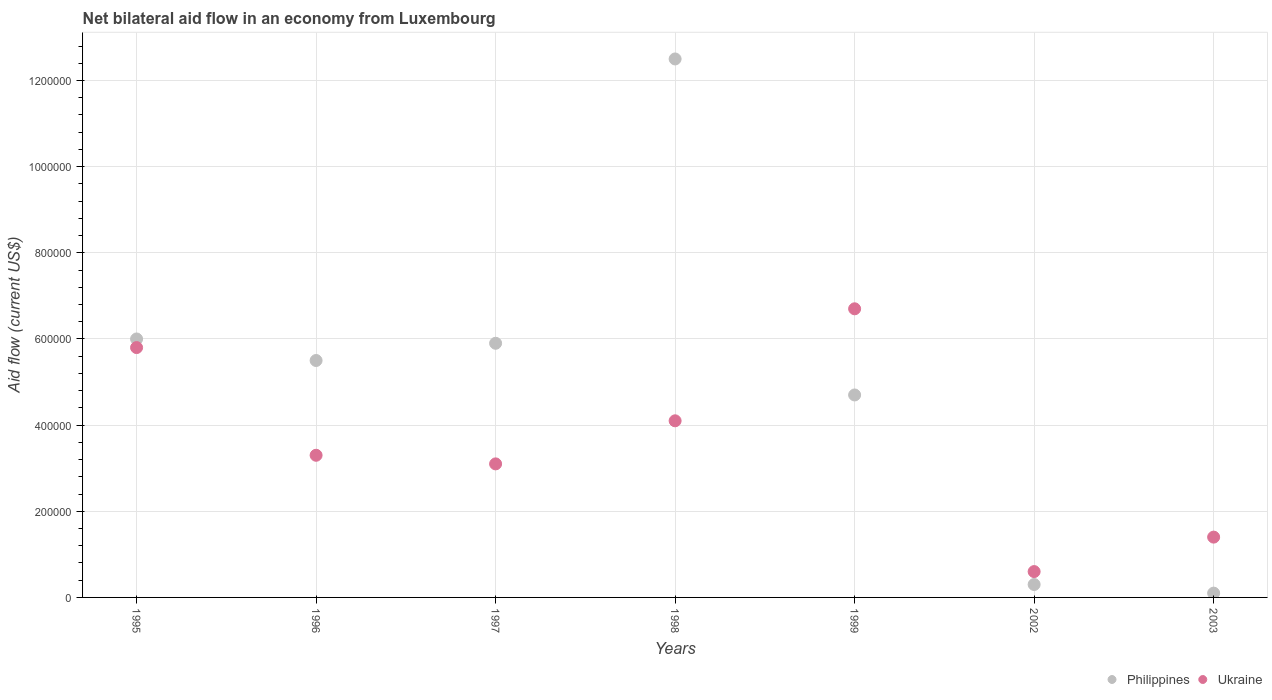What is the net bilateral aid flow in Philippines in 1997?
Your answer should be compact. 5.90e+05. Across all years, what is the maximum net bilateral aid flow in Philippines?
Ensure brevity in your answer.  1.25e+06. In which year was the net bilateral aid flow in Philippines maximum?
Your response must be concise. 1998. In which year was the net bilateral aid flow in Philippines minimum?
Give a very brief answer. 2003. What is the total net bilateral aid flow in Philippines in the graph?
Give a very brief answer. 3.50e+06. What is the difference between the net bilateral aid flow in Philippines in 1999 and that in 2003?
Provide a succinct answer. 4.60e+05. What is the difference between the net bilateral aid flow in Ukraine in 2003 and the net bilateral aid flow in Philippines in 1999?
Provide a short and direct response. -3.30e+05. What is the average net bilateral aid flow in Ukraine per year?
Keep it short and to the point. 3.57e+05. In the year 1998, what is the difference between the net bilateral aid flow in Philippines and net bilateral aid flow in Ukraine?
Make the answer very short. 8.40e+05. In how many years, is the net bilateral aid flow in Ukraine greater than 880000 US$?
Make the answer very short. 0. What is the ratio of the net bilateral aid flow in Ukraine in 1999 to that in 2003?
Your answer should be compact. 4.79. Is the difference between the net bilateral aid flow in Philippines in 1997 and 1998 greater than the difference between the net bilateral aid flow in Ukraine in 1997 and 1998?
Your answer should be very brief. No. What is the difference between the highest and the second highest net bilateral aid flow in Ukraine?
Provide a succinct answer. 9.00e+04. What is the difference between the highest and the lowest net bilateral aid flow in Philippines?
Offer a very short reply. 1.24e+06. In how many years, is the net bilateral aid flow in Philippines greater than the average net bilateral aid flow in Philippines taken over all years?
Make the answer very short. 4. Does the net bilateral aid flow in Ukraine monotonically increase over the years?
Make the answer very short. No. How many dotlines are there?
Offer a very short reply. 2. What is the title of the graph?
Offer a very short reply. Net bilateral aid flow in an economy from Luxembourg. Does "Suriname" appear as one of the legend labels in the graph?
Ensure brevity in your answer.  No. What is the label or title of the X-axis?
Offer a terse response. Years. What is the Aid flow (current US$) of Ukraine in 1995?
Your answer should be compact. 5.80e+05. What is the Aid flow (current US$) of Philippines in 1997?
Give a very brief answer. 5.90e+05. What is the Aid flow (current US$) in Philippines in 1998?
Keep it short and to the point. 1.25e+06. What is the Aid flow (current US$) in Ukraine in 1998?
Make the answer very short. 4.10e+05. What is the Aid flow (current US$) of Philippines in 1999?
Your answer should be very brief. 4.70e+05. What is the Aid flow (current US$) in Ukraine in 1999?
Your answer should be compact. 6.70e+05. What is the Aid flow (current US$) of Philippines in 2002?
Your answer should be very brief. 3.00e+04. Across all years, what is the maximum Aid flow (current US$) in Philippines?
Provide a succinct answer. 1.25e+06. Across all years, what is the maximum Aid flow (current US$) in Ukraine?
Provide a succinct answer. 6.70e+05. Across all years, what is the minimum Aid flow (current US$) of Ukraine?
Your answer should be very brief. 6.00e+04. What is the total Aid flow (current US$) of Philippines in the graph?
Your answer should be compact. 3.50e+06. What is the total Aid flow (current US$) in Ukraine in the graph?
Your response must be concise. 2.50e+06. What is the difference between the Aid flow (current US$) of Ukraine in 1995 and that in 1996?
Provide a short and direct response. 2.50e+05. What is the difference between the Aid flow (current US$) in Philippines in 1995 and that in 1997?
Keep it short and to the point. 10000. What is the difference between the Aid flow (current US$) in Philippines in 1995 and that in 1998?
Keep it short and to the point. -6.50e+05. What is the difference between the Aid flow (current US$) in Ukraine in 1995 and that in 1998?
Provide a succinct answer. 1.70e+05. What is the difference between the Aid flow (current US$) in Philippines in 1995 and that in 2002?
Provide a short and direct response. 5.70e+05. What is the difference between the Aid flow (current US$) of Ukraine in 1995 and that in 2002?
Your answer should be very brief. 5.20e+05. What is the difference between the Aid flow (current US$) of Philippines in 1995 and that in 2003?
Keep it short and to the point. 5.90e+05. What is the difference between the Aid flow (current US$) of Ukraine in 1995 and that in 2003?
Make the answer very short. 4.40e+05. What is the difference between the Aid flow (current US$) in Ukraine in 1996 and that in 1997?
Ensure brevity in your answer.  2.00e+04. What is the difference between the Aid flow (current US$) in Philippines in 1996 and that in 1998?
Your response must be concise. -7.00e+05. What is the difference between the Aid flow (current US$) of Philippines in 1996 and that in 1999?
Offer a terse response. 8.00e+04. What is the difference between the Aid flow (current US$) in Philippines in 1996 and that in 2002?
Offer a terse response. 5.20e+05. What is the difference between the Aid flow (current US$) in Ukraine in 1996 and that in 2002?
Provide a succinct answer. 2.70e+05. What is the difference between the Aid flow (current US$) in Philippines in 1996 and that in 2003?
Ensure brevity in your answer.  5.40e+05. What is the difference between the Aid flow (current US$) of Philippines in 1997 and that in 1998?
Your answer should be compact. -6.60e+05. What is the difference between the Aid flow (current US$) of Ukraine in 1997 and that in 1999?
Keep it short and to the point. -3.60e+05. What is the difference between the Aid flow (current US$) in Philippines in 1997 and that in 2002?
Make the answer very short. 5.60e+05. What is the difference between the Aid flow (current US$) in Ukraine in 1997 and that in 2002?
Your answer should be very brief. 2.50e+05. What is the difference between the Aid flow (current US$) in Philippines in 1997 and that in 2003?
Ensure brevity in your answer.  5.80e+05. What is the difference between the Aid flow (current US$) of Philippines in 1998 and that in 1999?
Your answer should be very brief. 7.80e+05. What is the difference between the Aid flow (current US$) in Philippines in 1998 and that in 2002?
Your response must be concise. 1.22e+06. What is the difference between the Aid flow (current US$) of Ukraine in 1998 and that in 2002?
Your response must be concise. 3.50e+05. What is the difference between the Aid flow (current US$) in Philippines in 1998 and that in 2003?
Your answer should be compact. 1.24e+06. What is the difference between the Aid flow (current US$) in Ukraine in 1998 and that in 2003?
Make the answer very short. 2.70e+05. What is the difference between the Aid flow (current US$) in Philippines in 1999 and that in 2002?
Offer a very short reply. 4.40e+05. What is the difference between the Aid flow (current US$) of Ukraine in 1999 and that in 2002?
Offer a terse response. 6.10e+05. What is the difference between the Aid flow (current US$) of Ukraine in 1999 and that in 2003?
Provide a succinct answer. 5.30e+05. What is the difference between the Aid flow (current US$) of Philippines in 2002 and that in 2003?
Give a very brief answer. 2.00e+04. What is the difference between the Aid flow (current US$) in Ukraine in 2002 and that in 2003?
Your answer should be very brief. -8.00e+04. What is the difference between the Aid flow (current US$) of Philippines in 1995 and the Aid flow (current US$) of Ukraine in 1997?
Give a very brief answer. 2.90e+05. What is the difference between the Aid flow (current US$) in Philippines in 1995 and the Aid flow (current US$) in Ukraine in 1999?
Offer a terse response. -7.00e+04. What is the difference between the Aid flow (current US$) in Philippines in 1995 and the Aid flow (current US$) in Ukraine in 2002?
Provide a short and direct response. 5.40e+05. What is the difference between the Aid flow (current US$) of Philippines in 1995 and the Aid flow (current US$) of Ukraine in 2003?
Give a very brief answer. 4.60e+05. What is the difference between the Aid flow (current US$) in Philippines in 1996 and the Aid flow (current US$) in Ukraine in 1997?
Your answer should be compact. 2.40e+05. What is the difference between the Aid flow (current US$) in Philippines in 1996 and the Aid flow (current US$) in Ukraine in 2002?
Your response must be concise. 4.90e+05. What is the difference between the Aid flow (current US$) in Philippines in 1997 and the Aid flow (current US$) in Ukraine in 1998?
Your answer should be very brief. 1.80e+05. What is the difference between the Aid flow (current US$) of Philippines in 1997 and the Aid flow (current US$) of Ukraine in 1999?
Offer a very short reply. -8.00e+04. What is the difference between the Aid flow (current US$) in Philippines in 1997 and the Aid flow (current US$) in Ukraine in 2002?
Offer a very short reply. 5.30e+05. What is the difference between the Aid flow (current US$) in Philippines in 1998 and the Aid flow (current US$) in Ukraine in 1999?
Your answer should be very brief. 5.80e+05. What is the difference between the Aid flow (current US$) of Philippines in 1998 and the Aid flow (current US$) of Ukraine in 2002?
Your answer should be compact. 1.19e+06. What is the difference between the Aid flow (current US$) in Philippines in 1998 and the Aid flow (current US$) in Ukraine in 2003?
Your answer should be compact. 1.11e+06. What is the difference between the Aid flow (current US$) in Philippines in 1999 and the Aid flow (current US$) in Ukraine in 2002?
Offer a terse response. 4.10e+05. What is the average Aid flow (current US$) in Ukraine per year?
Your answer should be very brief. 3.57e+05. In the year 1998, what is the difference between the Aid flow (current US$) in Philippines and Aid flow (current US$) in Ukraine?
Give a very brief answer. 8.40e+05. In the year 1999, what is the difference between the Aid flow (current US$) of Philippines and Aid flow (current US$) of Ukraine?
Ensure brevity in your answer.  -2.00e+05. What is the ratio of the Aid flow (current US$) in Philippines in 1995 to that in 1996?
Make the answer very short. 1.09. What is the ratio of the Aid flow (current US$) of Ukraine in 1995 to that in 1996?
Offer a terse response. 1.76. What is the ratio of the Aid flow (current US$) in Philippines in 1995 to that in 1997?
Your answer should be very brief. 1.02. What is the ratio of the Aid flow (current US$) in Ukraine in 1995 to that in 1997?
Provide a succinct answer. 1.87. What is the ratio of the Aid flow (current US$) in Philippines in 1995 to that in 1998?
Provide a short and direct response. 0.48. What is the ratio of the Aid flow (current US$) in Ukraine in 1995 to that in 1998?
Your answer should be very brief. 1.41. What is the ratio of the Aid flow (current US$) of Philippines in 1995 to that in 1999?
Offer a terse response. 1.28. What is the ratio of the Aid flow (current US$) of Ukraine in 1995 to that in 1999?
Offer a very short reply. 0.87. What is the ratio of the Aid flow (current US$) of Philippines in 1995 to that in 2002?
Give a very brief answer. 20. What is the ratio of the Aid flow (current US$) of Ukraine in 1995 to that in 2002?
Give a very brief answer. 9.67. What is the ratio of the Aid flow (current US$) in Philippines in 1995 to that in 2003?
Your answer should be compact. 60. What is the ratio of the Aid flow (current US$) of Ukraine in 1995 to that in 2003?
Keep it short and to the point. 4.14. What is the ratio of the Aid flow (current US$) of Philippines in 1996 to that in 1997?
Provide a succinct answer. 0.93. What is the ratio of the Aid flow (current US$) in Ukraine in 1996 to that in 1997?
Your answer should be compact. 1.06. What is the ratio of the Aid flow (current US$) in Philippines in 1996 to that in 1998?
Give a very brief answer. 0.44. What is the ratio of the Aid flow (current US$) of Ukraine in 1996 to that in 1998?
Offer a very short reply. 0.8. What is the ratio of the Aid flow (current US$) of Philippines in 1996 to that in 1999?
Provide a short and direct response. 1.17. What is the ratio of the Aid flow (current US$) in Ukraine in 1996 to that in 1999?
Your answer should be very brief. 0.49. What is the ratio of the Aid flow (current US$) of Philippines in 1996 to that in 2002?
Keep it short and to the point. 18.33. What is the ratio of the Aid flow (current US$) of Ukraine in 1996 to that in 2003?
Your response must be concise. 2.36. What is the ratio of the Aid flow (current US$) of Philippines in 1997 to that in 1998?
Give a very brief answer. 0.47. What is the ratio of the Aid flow (current US$) in Ukraine in 1997 to that in 1998?
Offer a very short reply. 0.76. What is the ratio of the Aid flow (current US$) in Philippines in 1997 to that in 1999?
Your response must be concise. 1.26. What is the ratio of the Aid flow (current US$) in Ukraine in 1997 to that in 1999?
Your answer should be very brief. 0.46. What is the ratio of the Aid flow (current US$) in Philippines in 1997 to that in 2002?
Give a very brief answer. 19.67. What is the ratio of the Aid flow (current US$) of Ukraine in 1997 to that in 2002?
Ensure brevity in your answer.  5.17. What is the ratio of the Aid flow (current US$) of Philippines in 1997 to that in 2003?
Ensure brevity in your answer.  59. What is the ratio of the Aid flow (current US$) of Ukraine in 1997 to that in 2003?
Keep it short and to the point. 2.21. What is the ratio of the Aid flow (current US$) in Philippines in 1998 to that in 1999?
Provide a succinct answer. 2.66. What is the ratio of the Aid flow (current US$) in Ukraine in 1998 to that in 1999?
Ensure brevity in your answer.  0.61. What is the ratio of the Aid flow (current US$) of Philippines in 1998 to that in 2002?
Provide a succinct answer. 41.67. What is the ratio of the Aid flow (current US$) in Ukraine in 1998 to that in 2002?
Your answer should be very brief. 6.83. What is the ratio of the Aid flow (current US$) of Philippines in 1998 to that in 2003?
Make the answer very short. 125. What is the ratio of the Aid flow (current US$) in Ukraine in 1998 to that in 2003?
Make the answer very short. 2.93. What is the ratio of the Aid flow (current US$) in Philippines in 1999 to that in 2002?
Offer a terse response. 15.67. What is the ratio of the Aid flow (current US$) of Ukraine in 1999 to that in 2002?
Keep it short and to the point. 11.17. What is the ratio of the Aid flow (current US$) of Philippines in 1999 to that in 2003?
Your answer should be compact. 47. What is the ratio of the Aid flow (current US$) in Ukraine in 1999 to that in 2003?
Provide a short and direct response. 4.79. What is the ratio of the Aid flow (current US$) in Ukraine in 2002 to that in 2003?
Keep it short and to the point. 0.43. What is the difference between the highest and the second highest Aid flow (current US$) in Philippines?
Your answer should be compact. 6.50e+05. What is the difference between the highest and the second highest Aid flow (current US$) of Ukraine?
Provide a succinct answer. 9.00e+04. What is the difference between the highest and the lowest Aid flow (current US$) of Philippines?
Keep it short and to the point. 1.24e+06. 